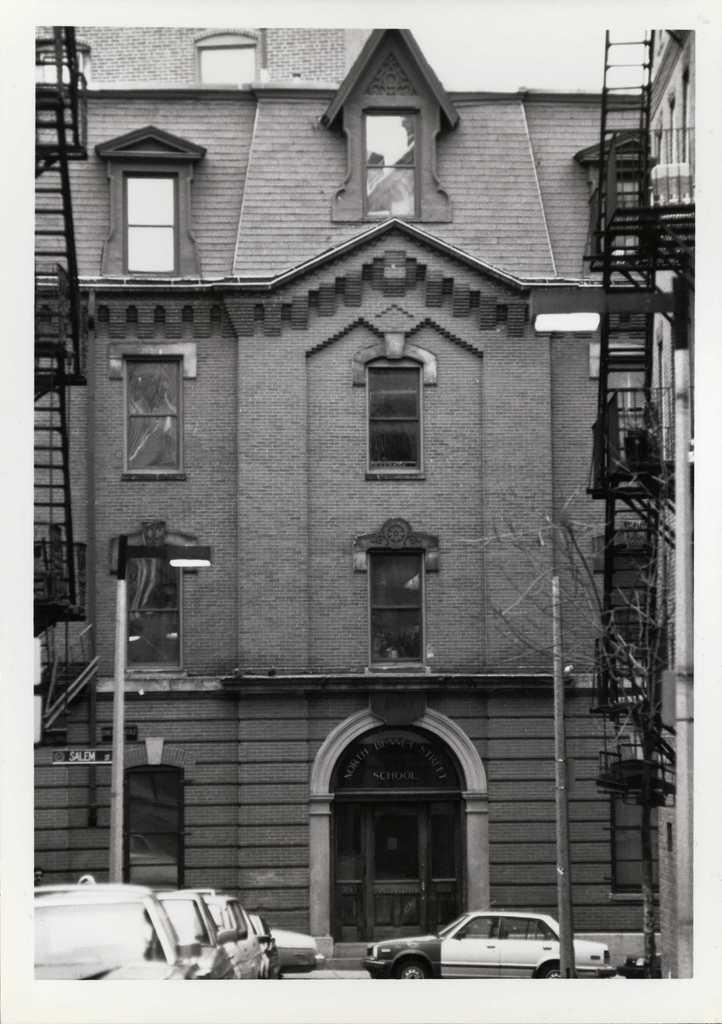What type of structure is visible in the image? There is a building in the image. What features can be seen on the building? The building has windows and doors. What other objects are present in the image? There are light-poles, vehicles, and stairs in the image. How is the image presented? The image is in black and white. What type of punishment is being administered in the image? There is no indication of punishment in the image; it features a building with various objects and features. What kind of ray is visible in the image? There is no ray present in the image; it is a black and white image of a building and its surroundings. 